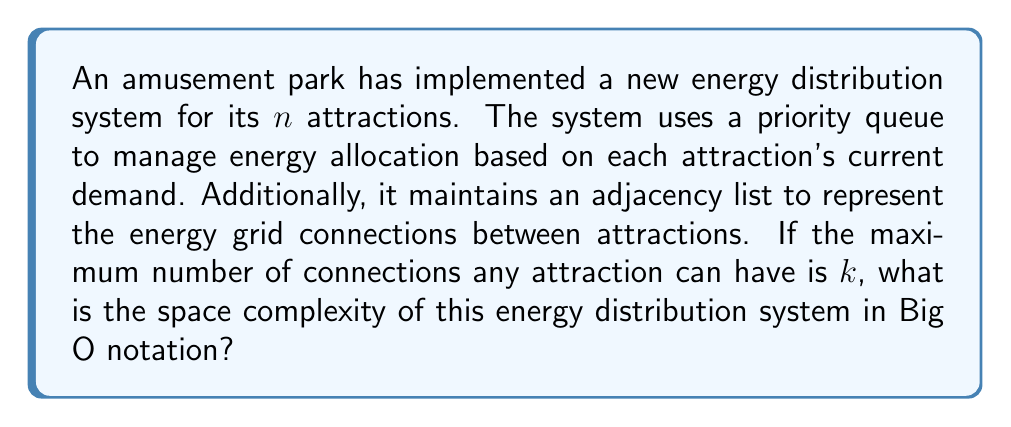Help me with this question. To analyze the space complexity of this energy distribution system, we need to consider the space required by its two main components:

1. Priority Queue:
   - The priority queue contains information for all $n$ attractions.
   - Each attraction in the queue requires constant space (e.g., for storing its identifier and current energy demand).
   - Therefore, the space complexity of the priority queue is $O(n)$.

2. Adjacency List:
   - The adjacency list represents the energy grid connections between attractions.
   - There are $n$ attractions, so we have $n$ lists.
   - Each attraction can have at most $k$ connections.
   - Thus, the total space required for the adjacency list is $O(n \cdot k)$.

To determine the overall space complexity, we add these components:

$$O(n) + O(n \cdot k) = O(n + nk)$$

Since $k$ is a constant (the maximum number of connections per attraction), we can simplify this to:

$$O(n + nk) = O(n(1 + k)) = O(n)$$

This simplification is possible because when $k$ is constant, $n$ dominates the growth rate as $n$ increases.
Answer: The space complexity of the energy distribution system is $O(n)$, where $n$ is the number of attractions in the amusement park. 